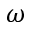Convert formula to latex. <formula><loc_0><loc_0><loc_500><loc_500>\omega</formula> 